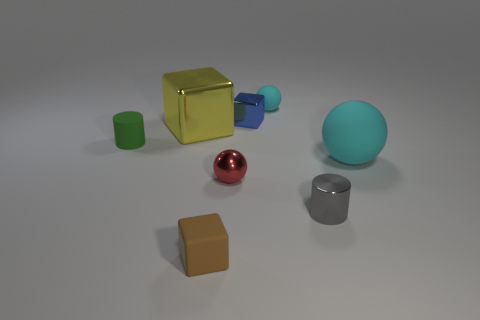Are there any tiny gray cylinders behind the red shiny ball?
Provide a short and direct response. No. The other object that is the same size as the yellow metallic thing is what color?
Keep it short and to the point. Cyan. What number of large yellow blocks have the same material as the red sphere?
Your answer should be very brief. 1. How many other things are there of the same size as the green rubber object?
Offer a terse response. 5. Are there any other yellow objects that have the same size as the yellow thing?
Your answer should be compact. No. Do the shiny block that is left of the metallic ball and the shiny sphere have the same color?
Your response must be concise. No. What number of objects are small red metal objects or gray cylinders?
Provide a succinct answer. 2. There is a matte object in front of the red thing; is it the same size as the blue block?
Provide a short and direct response. Yes. What size is the object that is on the left side of the red sphere and behind the tiny green cylinder?
Offer a very short reply. Large. What number of other objects are the same shape as the blue thing?
Offer a terse response. 2. 